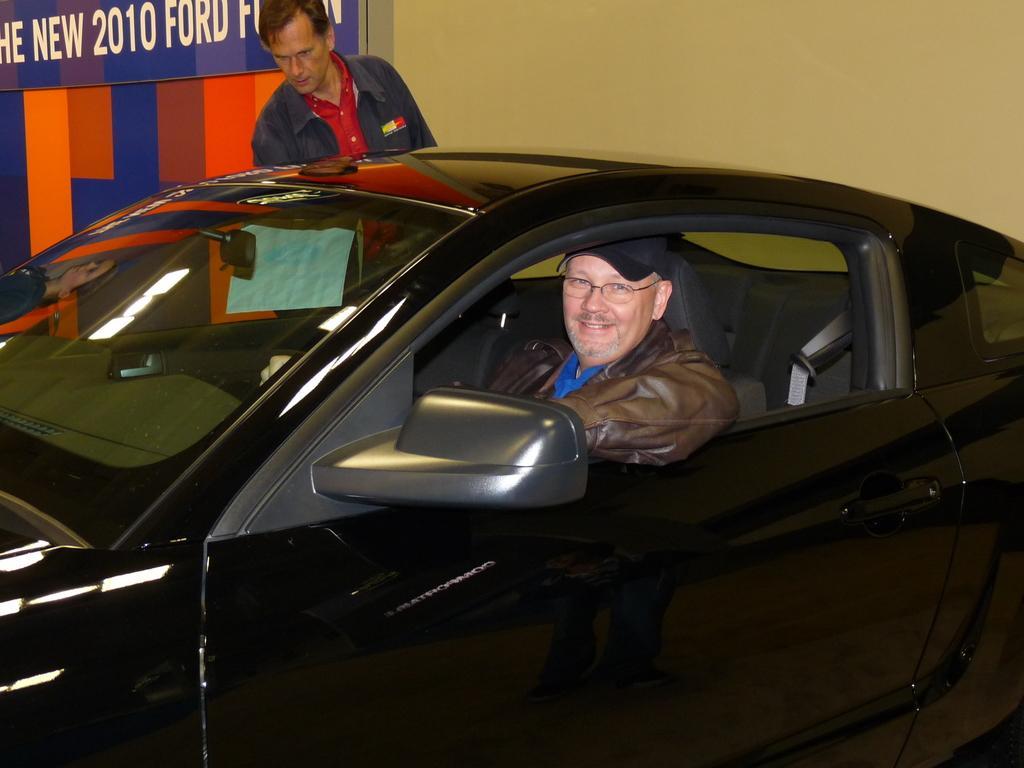Describe this image in one or two sentences. In this image there are two persons, one person is sitting inside the car and other person is standing behind the car. At the back there is a hoarding. 